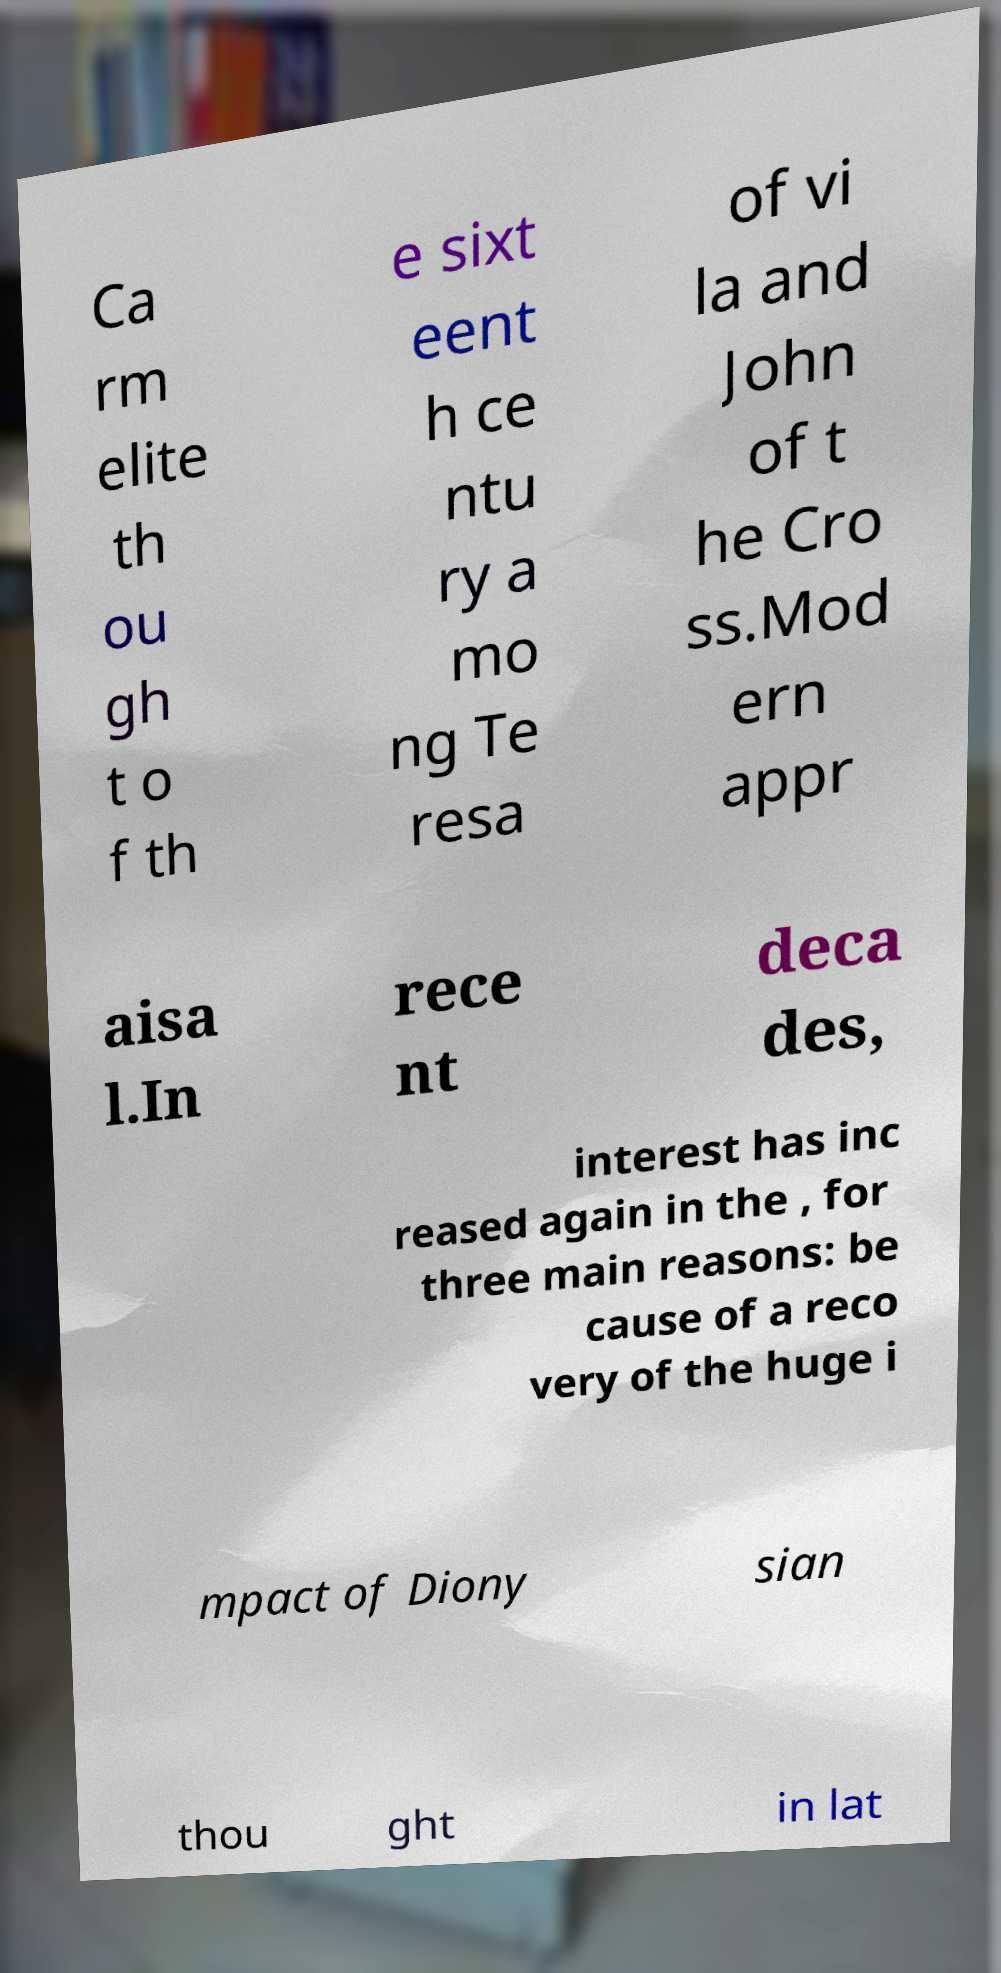What messages or text are displayed in this image? I need them in a readable, typed format. Ca rm elite th ou gh t o f th e sixt eent h ce ntu ry a mo ng Te resa of vi la and John of t he Cro ss.Mod ern appr aisa l.In rece nt deca des, interest has inc reased again in the , for three main reasons: be cause of a reco very of the huge i mpact of Diony sian thou ght in lat 